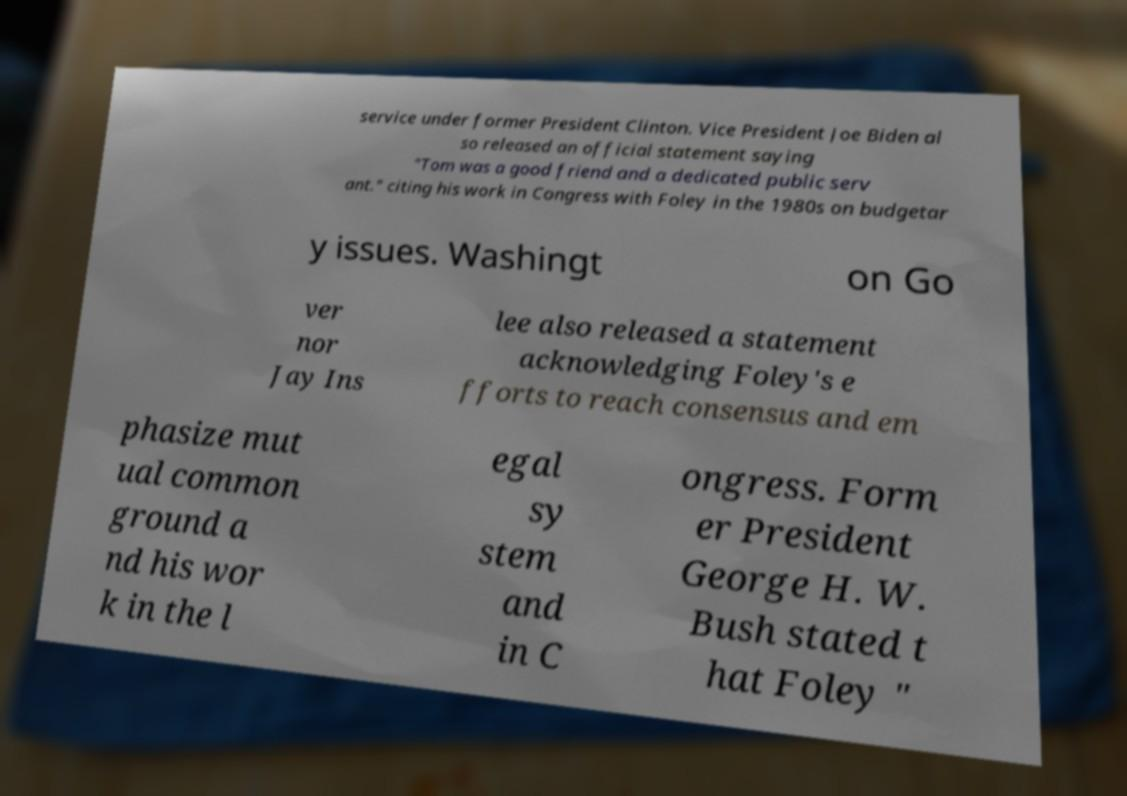Can you accurately transcribe the text from the provided image for me? service under former President Clinton. Vice President Joe Biden al so released an official statement saying "Tom was a good friend and a dedicated public serv ant." citing his work in Congress with Foley in the 1980s on budgetar y issues. Washingt on Go ver nor Jay Ins lee also released a statement acknowledging Foley's e fforts to reach consensus and em phasize mut ual common ground a nd his wor k in the l egal sy stem and in C ongress. Form er President George H. W. Bush stated t hat Foley " 